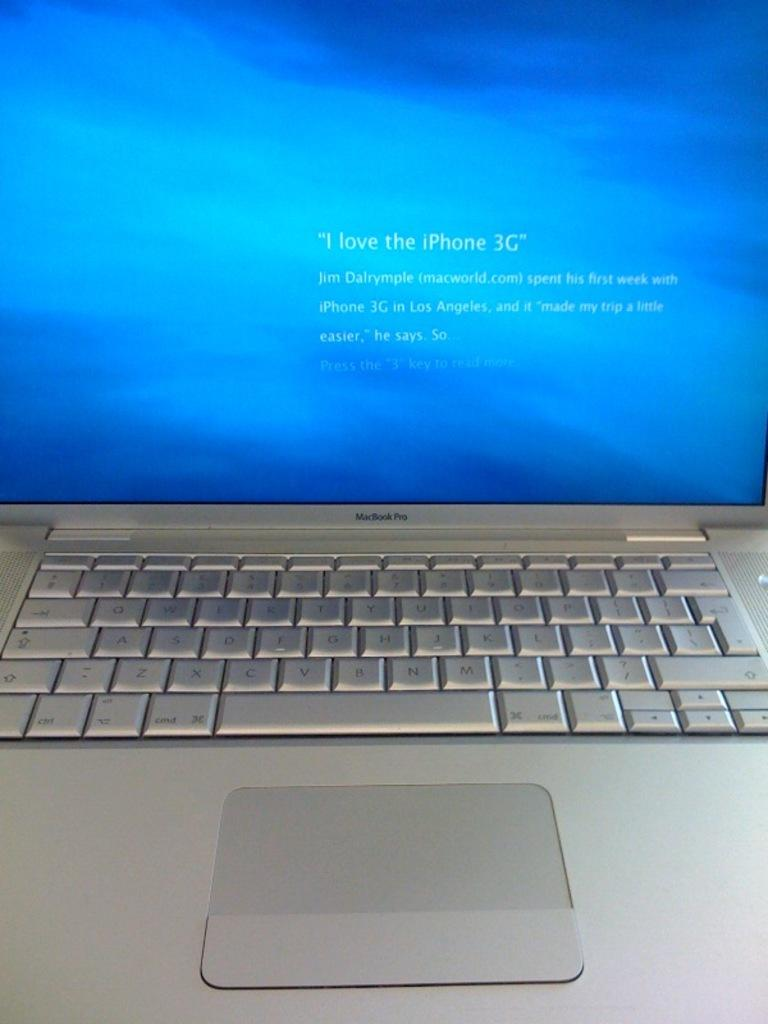<image>
Create a compact narrative representing the image presented. A MacBook Pro screen says I love the iPhone 3G. 